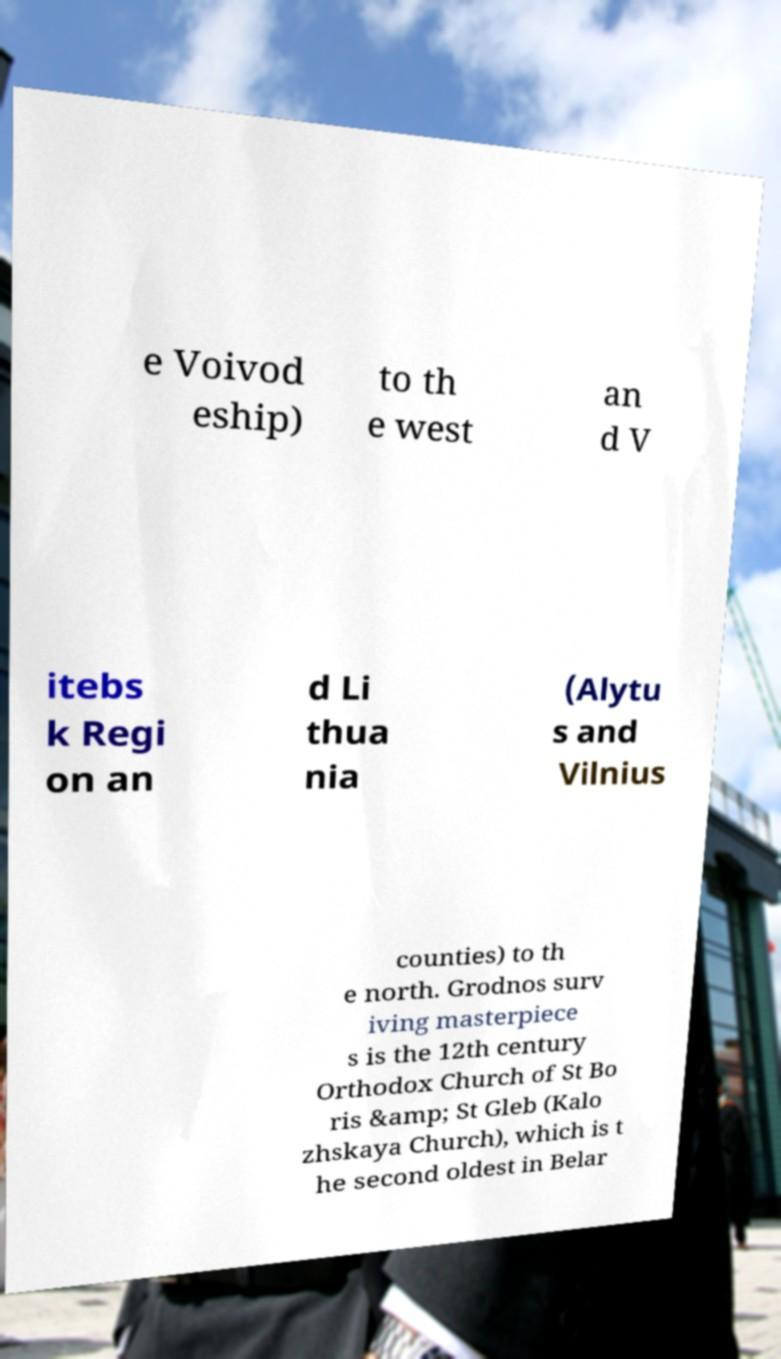There's text embedded in this image that I need extracted. Can you transcribe it verbatim? e Voivod eship) to th e west an d V itebs k Regi on an d Li thua nia (Alytu s and Vilnius counties) to th e north. Grodnos surv iving masterpiece s is the 12th century Orthodox Church of St Bo ris &amp; St Gleb (Kalo zhskaya Church), which is t he second oldest in Belar 